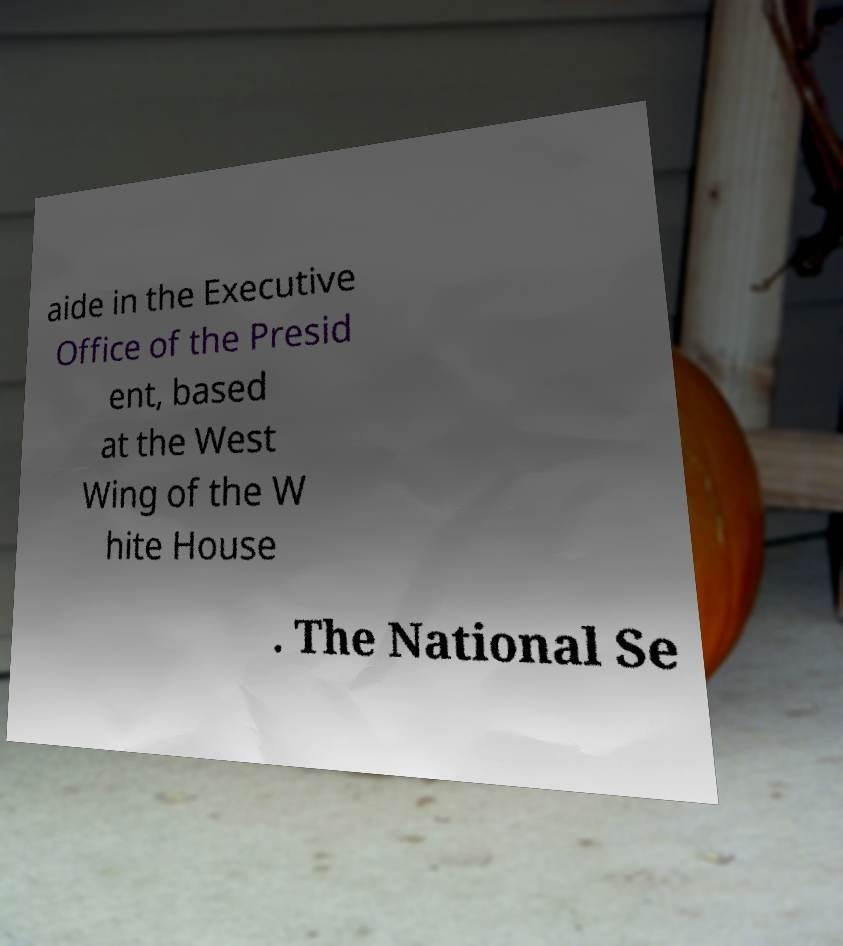I need the written content from this picture converted into text. Can you do that? aide in the Executive Office of the Presid ent, based at the West Wing of the W hite House . The National Se 